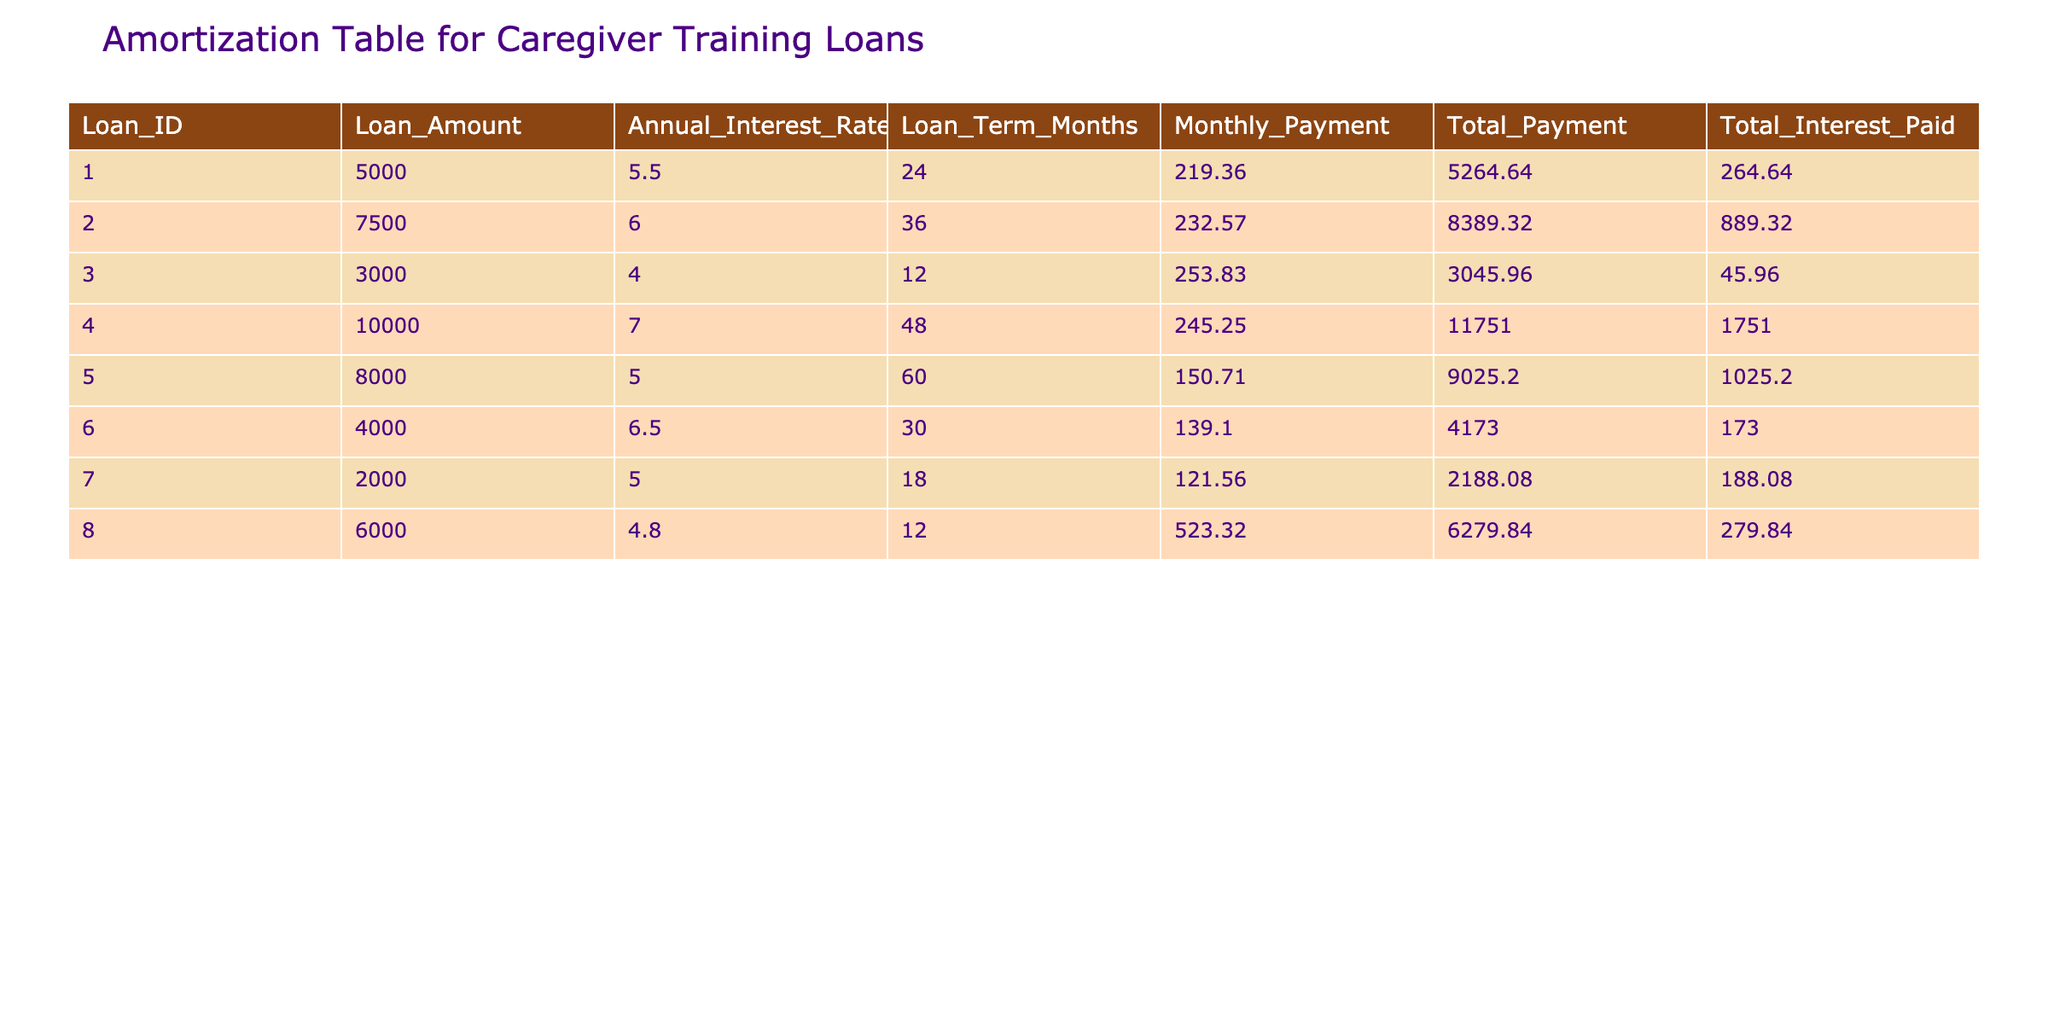What is the loan amount for Loan_ID 5? The table shows that the amount listed under the "Loan_Amount" column for Loan_ID 5 is 8000.
Answer: 8000 What is the total interest paid for the loan with Loan_ID 1? From the table, we can see that the "Total_Interest_Paid" for Loan_ID 1 is 264.64.
Answer: 264.64 Which loan has the highest total payment and what is that amount? By examining the "Total_Payment" column, Loan_ID 4 has the highest total payment of 11751.00.
Answer: 11751.00 What is the monthly payment for the loan with the shortest term? The shortest loan term is 12 months, which corresponds to Loan_ID 3, with a monthly payment of 253.83.
Answer: 253.83 Is the total interest paid for Loan_ID 2 greater than 800? The table indicates that the "Total_Interest_Paid" for Loan_ID 2 is 889.32, which is indeed greater than 800.
Answer: Yes What’s the average monthly payment across all loans? To find the average monthly payment, sum the monthly payments (219.36 + 232.57 + 253.83 + 245.25 + 150.71 + 139.10 + 121.56 + 523.32) which equals 1,885.10. Then divide by the number of loans (8), resulting in an average of 235.64.
Answer: 235.64 Is the loan term for Loan_ID 6 longer than that of Loan_ID 5? Loan_ID 6 has a term of 30 months while Loan_ID 5 has a term of 60 months, so Loan_ID 6 is shorter.
Answer: No What is the total payment for loans with an annual interest rate less than 5%? Only Loan_ID 3 has an annual interest rate of 4.0% and its total payment is 3045.96; thus that is the only total payment to consider.
Answer: 3045.96 Which loan has the lowest interest rate, and what is the loan amount? Upon reviewing the data, Loan_ID 3 has the lowest interest rate of 4.0%, with a loan amount of 3000.
Answer: 3000 